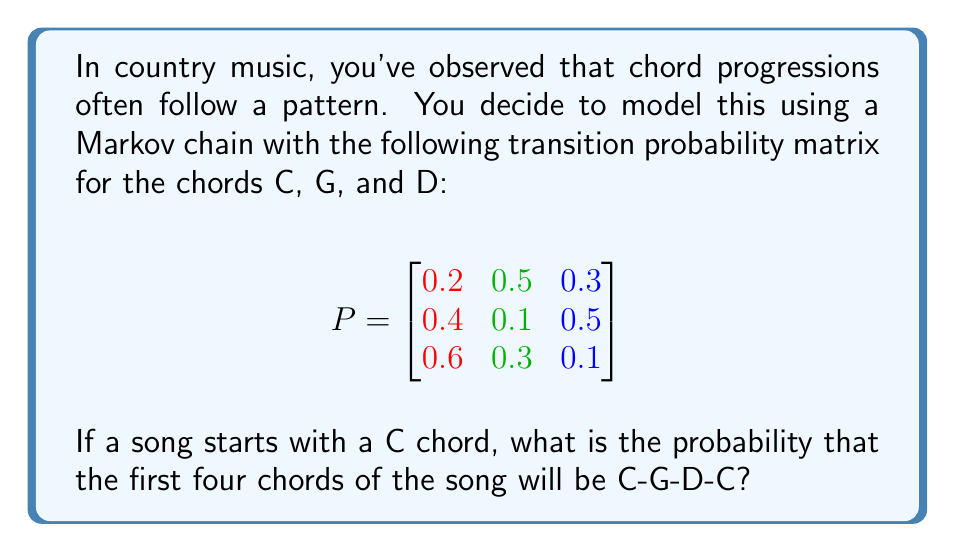What is the answer to this math problem? Let's approach this step-by-step:

1) We need to calculate the probability of the sequence C-G-D-C. In a Markov chain, the probability of a sequence is the product of the individual transition probabilities.

2) Let's break down the sequence:
   - C to G
   - G to D
   - D to C

3) From the given matrix:
   - P(G|C) = 0.5 (row 1, column 2)
   - P(D|G) = 0.5 (row 2, column 3)
   - P(C|D) = 0.6 (row 3, column 1)

4) The probability of the sequence is the product of these probabilities:

   $$P(\text{C-G-D-C}) = P(G|C) \times P(D|G) \times P(C|D)$$

5) Substituting the values:

   $$P(\text{C-G-D-C}) = 0.5 \times 0.5 \times 0.6$$

6) Calculating:

   $$P(\text{C-G-D-C}) = 0.15$$

Therefore, the probability of the chord progression C-G-D-C, given that the song starts with C, is 0.15 or 15%.
Answer: 0.15 